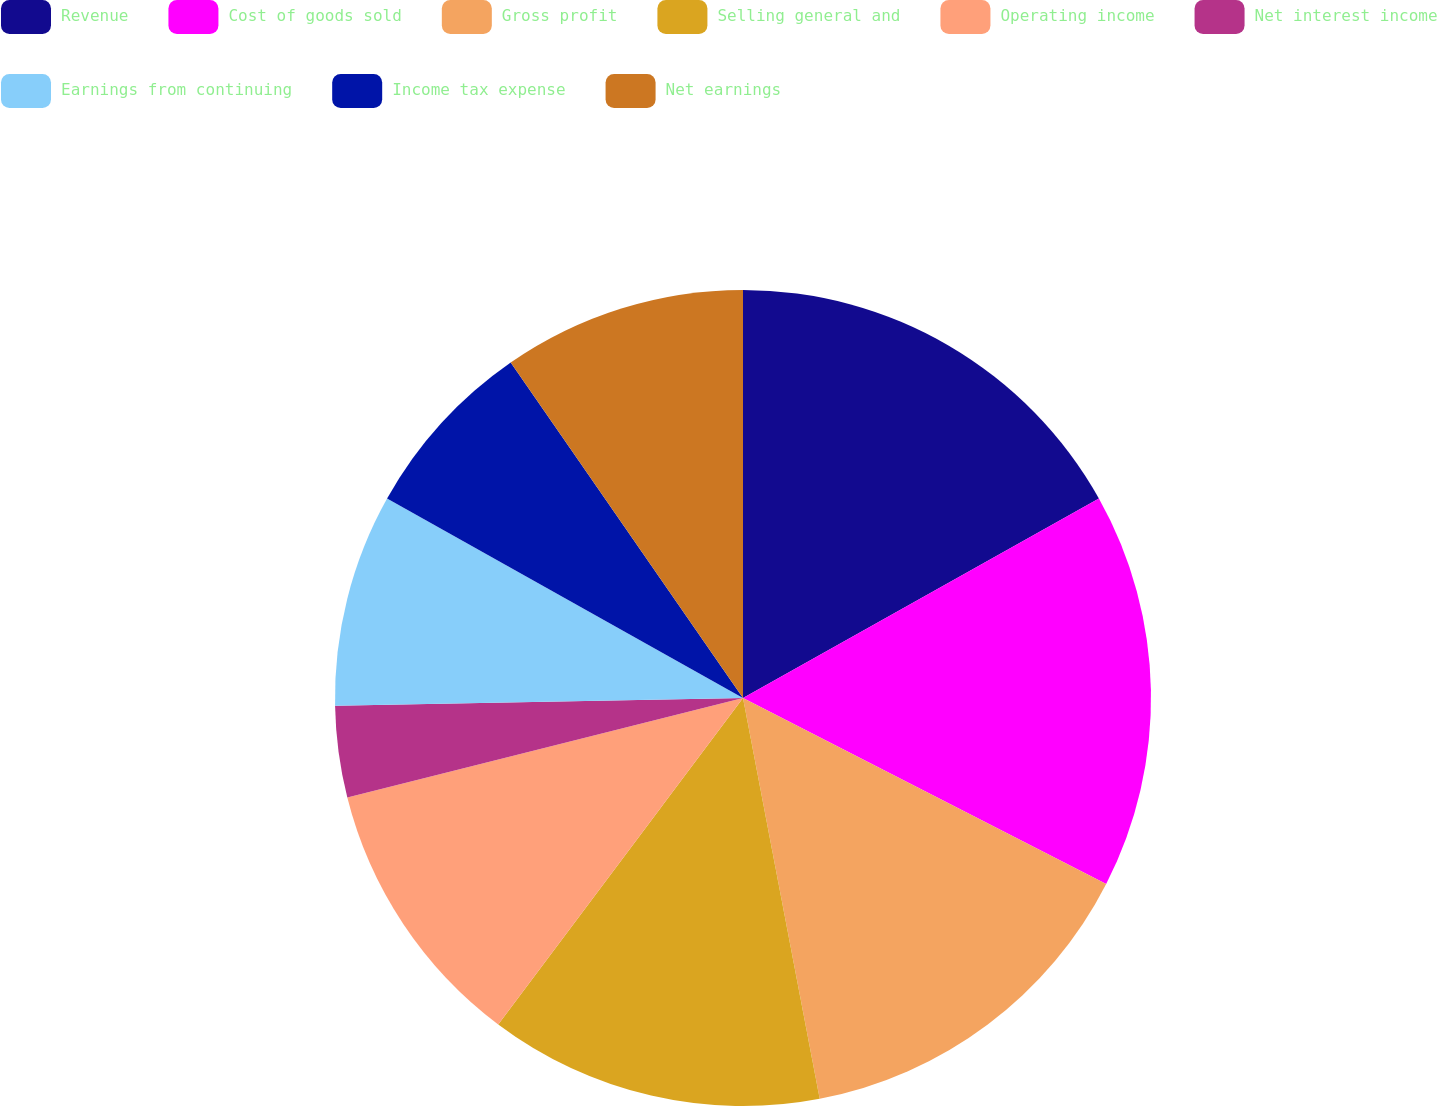Convert chart to OTSL. <chart><loc_0><loc_0><loc_500><loc_500><pie_chart><fcel>Revenue<fcel>Cost of goods sold<fcel>Gross profit<fcel>Selling general and<fcel>Operating income<fcel>Net interest income<fcel>Earnings from continuing<fcel>Income tax expense<fcel>Net earnings<nl><fcel>16.87%<fcel>15.66%<fcel>14.46%<fcel>13.25%<fcel>10.84%<fcel>3.62%<fcel>8.43%<fcel>7.23%<fcel>9.64%<nl></chart> 